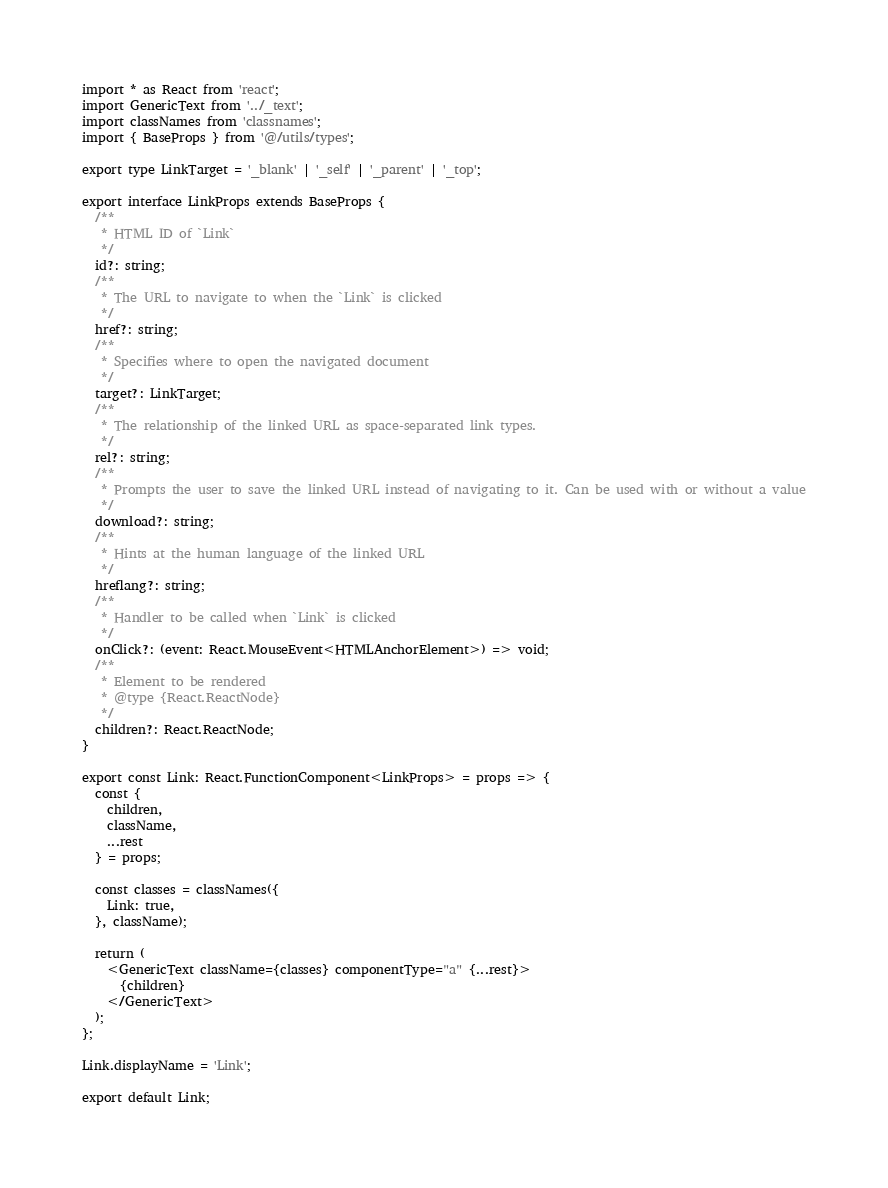<code> <loc_0><loc_0><loc_500><loc_500><_TypeScript_>import * as React from 'react';
import GenericText from '../_text';
import classNames from 'classnames';
import { BaseProps } from '@/utils/types';

export type LinkTarget = '_blank' | '_self' | '_parent' | '_top';

export interface LinkProps extends BaseProps {
  /**
   * HTML ID of `Link`
   */
  id?: string;
  /**
   * The URL to navigate to when the `Link` is clicked
   */
  href?: string;
  /**
   * Specifies where to open the navigated document
   */
  target?: LinkTarget;
  /**
   * The relationship of the linked URL as space-separated link types.
   */
  rel?: string;
  /**
   * Prompts the user to save the linked URL instead of navigating to it. Can be used with or without a value
   */
  download?: string;
  /**
   * Hints at the human language of the linked URL
   */
  hreflang?: string;
  /**
   * Handler to be called when `Link` is clicked
   */
  onClick?: (event: React.MouseEvent<HTMLAnchorElement>) => void;
  /**
   * Element to be rendered
   * @type {React.ReactNode}
   */
  children?: React.ReactNode;
}

export const Link: React.FunctionComponent<LinkProps> = props => {
  const {
    children,
    className,
    ...rest
  } = props;

  const classes = classNames({
    Link: true,
  }, className);

  return (
    <GenericText className={classes} componentType="a" {...rest}>
      {children}
    </GenericText>
  );
};

Link.displayName = 'Link';

export default Link;
</code> 